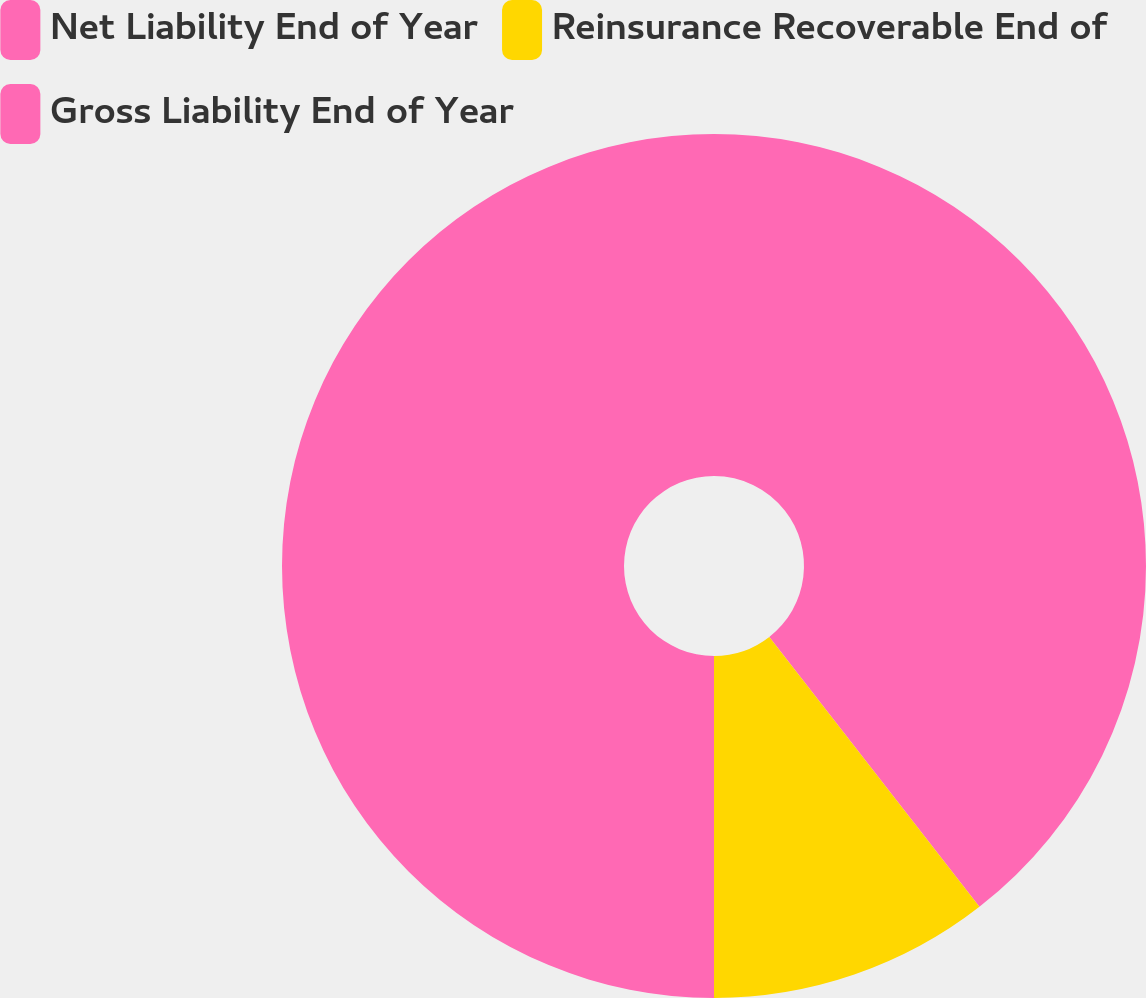Convert chart. <chart><loc_0><loc_0><loc_500><loc_500><pie_chart><fcel>Net Liability End of Year<fcel>Reinsurance Recoverable End of<fcel>Gross Liability End of Year<nl><fcel>39.47%<fcel>10.53%<fcel>50.0%<nl></chart> 